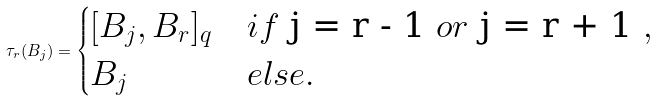<formula> <loc_0><loc_0><loc_500><loc_500>\tau _ { r } ( B _ { j } ) = \begin{cases} [ B _ { j } , B _ { r } ] _ { q } & i f $ j = r - 1 $ o r $ j = r + 1 $ , \\ B _ { j } & e l s e . \end{cases}</formula> 